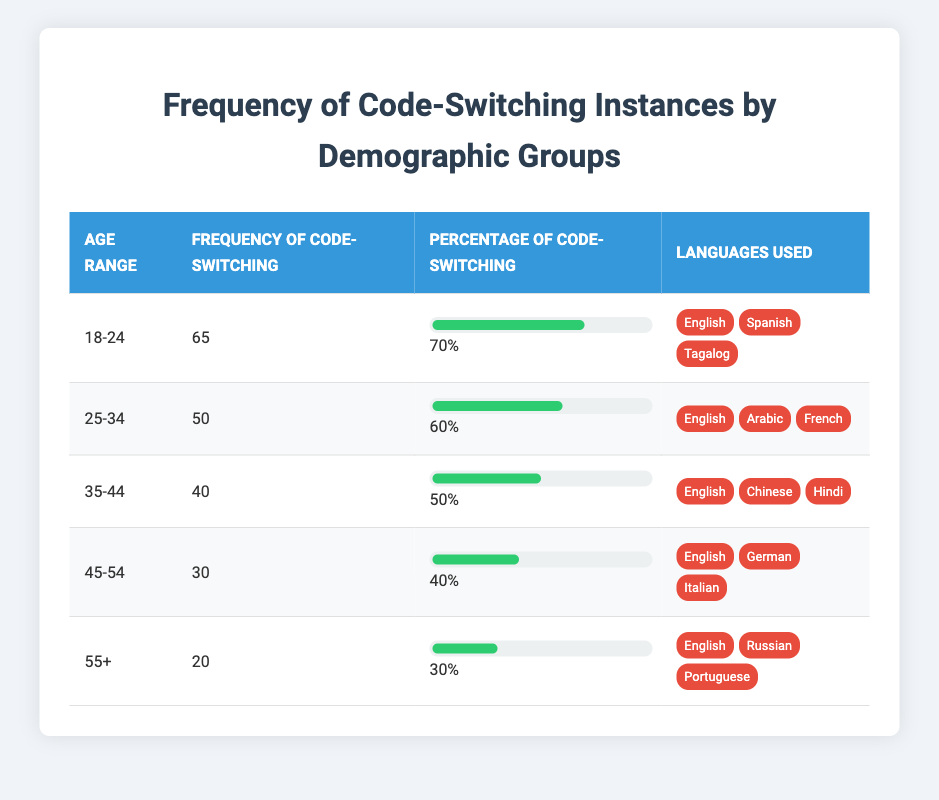What is the frequency of code-switching for the age range 35-44? By looking at the table, under the "Frequency of Code-Switching" column for the age range "35-44," the value is 40.
Answer: 40 Which demographic group has the highest percentage of code-switching? Referring to the "Percentage of Code-Switching" column, the highest percentage is 70%, which corresponds to the age range "18-24."
Answer: 18-24 What are the languages used by the 45-54 age range? The table lists the languages used for the age range "45-54" as English, German, and Italian.
Answer: English, German, Italian Is the frequency of code-switching higher in the 25-34 age range compared to the 35-44 age range? The frequency for 25-34 is 50, and for 35-44 is 40. Since 50 is greater than 40, the statement is true.
Answer: Yes What is the average frequency of code-switching across all demographic groups? To calculate the average, add the frequencies: 65 + 50 + 40 + 30 + 20 = 205. There are 5 groups, so the average frequency is 205 / 5 = 41.
Answer: 41 What is the total percentage of code-switching among the groups aged 45-54 and 55+? The percentage for 45-54 is 40%, and for 55+ it is 30%. Adding these together: 40 + 30 = 70%.
Answer: 70% Which group has the lowest frequency of code-switching? By examining the "Frequency of Code-Switching," the lowest frequency is 20, which corresponds to the age range "55+."
Answer: 55+ Do the languages used in the 35-44 group include Tagalog? The list for 35-44 includes English, Chinese, and Hindi, but does not mention Tagalog; hence, the statement is false.
Answer: No If you compare the frequency of code-switching between ages 25-34 and 45-54, what is the difference? The frequency for 25-34 is 50 and for 45-54 is 30. The difference is calculated by subtracting: 50 - 30 = 20.
Answer: 20 